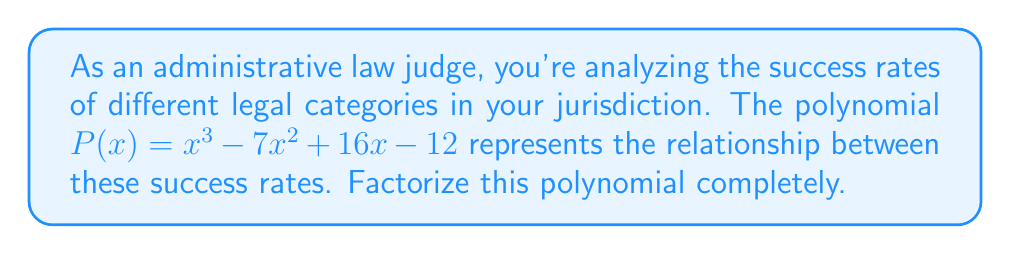Show me your answer to this math problem. Let's approach this step-by-step:

1) First, we'll check if there are any rational roots using the rational root theorem. The possible rational roots are the factors of the constant term: ±1, ±2, ±3, ±4, ±6, ±12.

2) Testing these values, we find that $P(1) = 0$. So $(x-1)$ is a factor.

3) We can use polynomial long division to divide $P(x)$ by $(x-1)$:

   $x^3 - 7x^2 + 16x - 12 = (x-1)(x^2 - 6x + 12)$

4) Now we need to factor the quadratic $x^2 - 6x + 12$. Let's use the quadratic formula:

   $x = \frac{-b \pm \sqrt{b^2 - 4ac}}{2a}$

   Where $a=1$, $b=-6$, and $c=12$

5) Substituting these values:

   $x = \frac{6 \pm \sqrt{36 - 48}}{2} = \frac{6 \pm \sqrt{-12}}{2}$

6) Since we have a negative value under the square root, this quadratic doesn't have real roots. It can't be factored further over the real numbers.

7) Therefore, the complete factorization is:

   $P(x) = (x-1)(x^2 - 6x + 12)$

This factorization represents the breakdown of success rates in different legal categories, with one linear factor and one irreducible quadratic factor.
Answer: $(x-1)(x^2 - 6x + 12)$ 